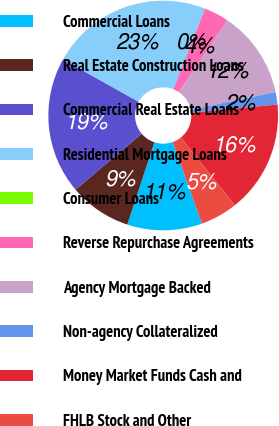Convert chart. <chart><loc_0><loc_0><loc_500><loc_500><pie_chart><fcel>Commercial Loans<fcel>Real Estate Construction Loans<fcel>Commercial Real Estate Loans<fcel>Residential Mortgage Loans<fcel>Consumer Loans<fcel>Reverse Repurchase Agreements<fcel>Agency Mortgage Backed<fcel>Non-agency Collateralized<fcel>Money Market Funds Cash and<fcel>FHLB Stock and Other<nl><fcel>10.53%<fcel>8.77%<fcel>19.3%<fcel>22.8%<fcel>0.0%<fcel>3.51%<fcel>12.28%<fcel>1.76%<fcel>15.79%<fcel>5.26%<nl></chart> 